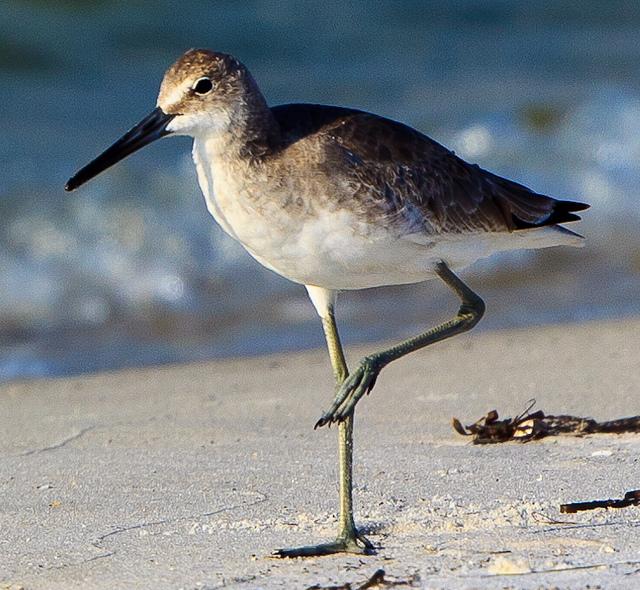What type of animal is this?
Short answer required. Bird. Which foot of the bird's is lifted up?
Be succinct. Left. What is the bird standing on?
Write a very short answer. Sand. 